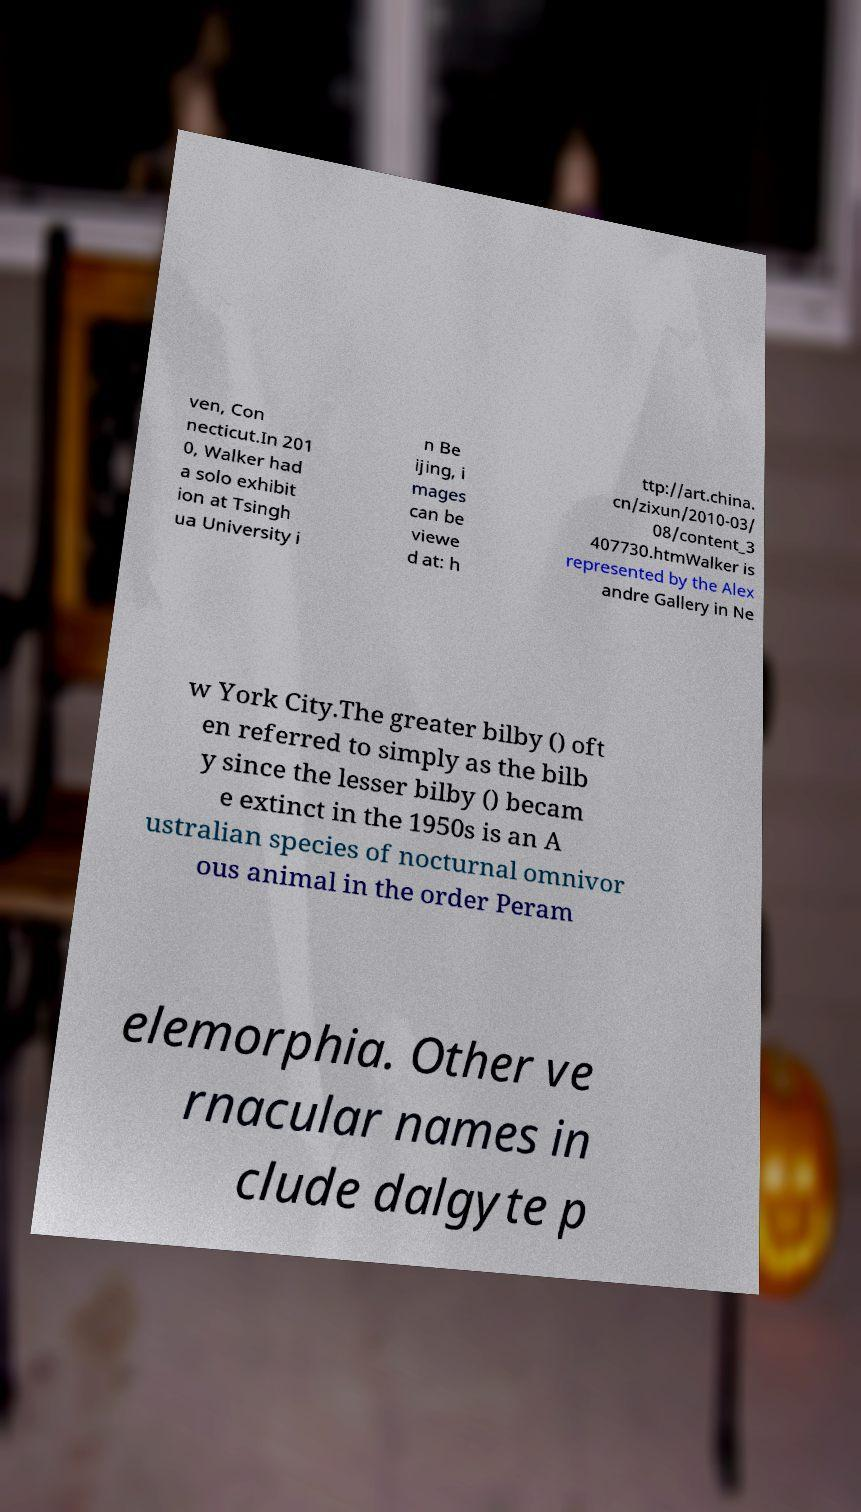For documentation purposes, I need the text within this image transcribed. Could you provide that? ven, Con necticut.In 201 0, Walker had a solo exhibit ion at Tsingh ua University i n Be ijing, i mages can be viewe d at: h ttp://art.china. cn/zixun/2010-03/ 08/content_3 407730.htmWalker is represented by the Alex andre Gallery in Ne w York City.The greater bilby () oft en referred to simply as the bilb y since the lesser bilby () becam e extinct in the 1950s is an A ustralian species of nocturnal omnivor ous animal in the order Peram elemorphia. Other ve rnacular names in clude dalgyte p 